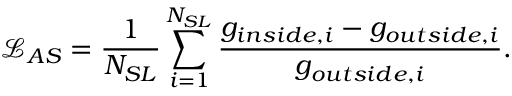<formula> <loc_0><loc_0><loc_500><loc_500>\mathcal { L } _ { A S } = \frac { 1 } { N _ { S L } } \sum _ { i = 1 } ^ { N _ { S L } } \frac { g _ { i n s i d e , i } - g _ { o u t s i d e , i } } { g _ { o u t s i d e , i } } .</formula> 